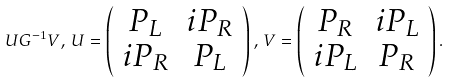<formula> <loc_0><loc_0><loc_500><loc_500>U G ^ { - 1 } V , \, U = \left ( \begin{array} { c c } { { P _ { L } } } & { { i P _ { R } } } \\ { { i P _ { R } } } & { { P _ { L } } } \end{array} \right ) , \, V = \left ( \begin{array} { c c } { { P _ { R } } } & { { i P _ { L } } } \\ { { i P _ { L } } } & { { P _ { R } } } \end{array} \right ) .</formula> 